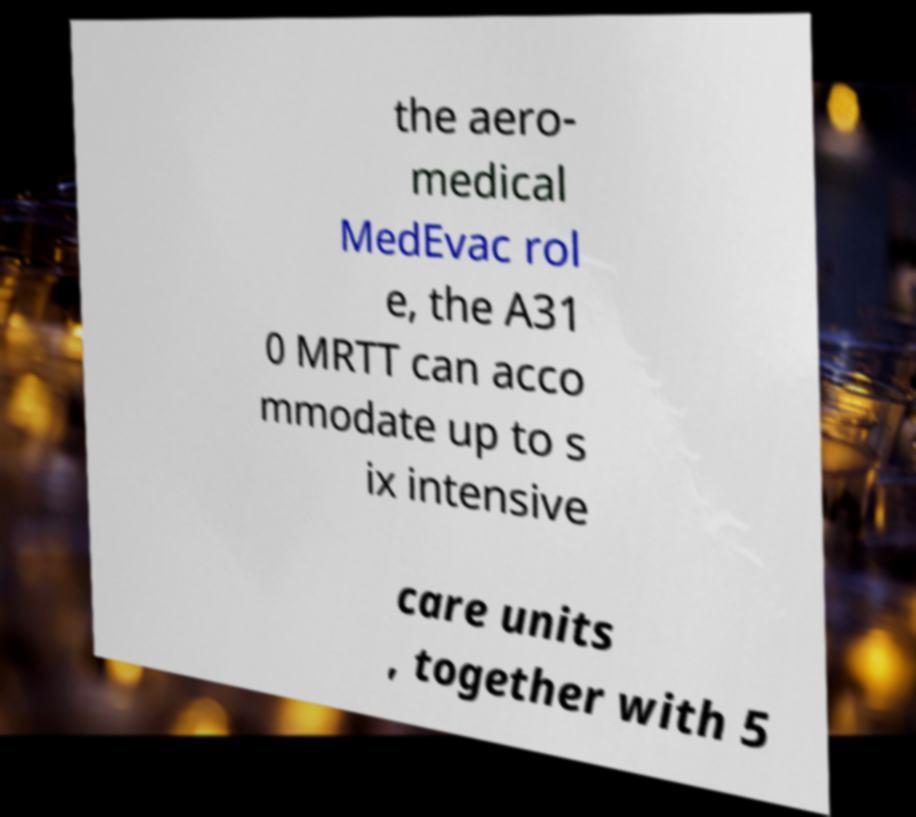Can you accurately transcribe the text from the provided image for me? the aero- medical MedEvac rol e, the A31 0 MRTT can acco mmodate up to s ix intensive care units , together with 5 